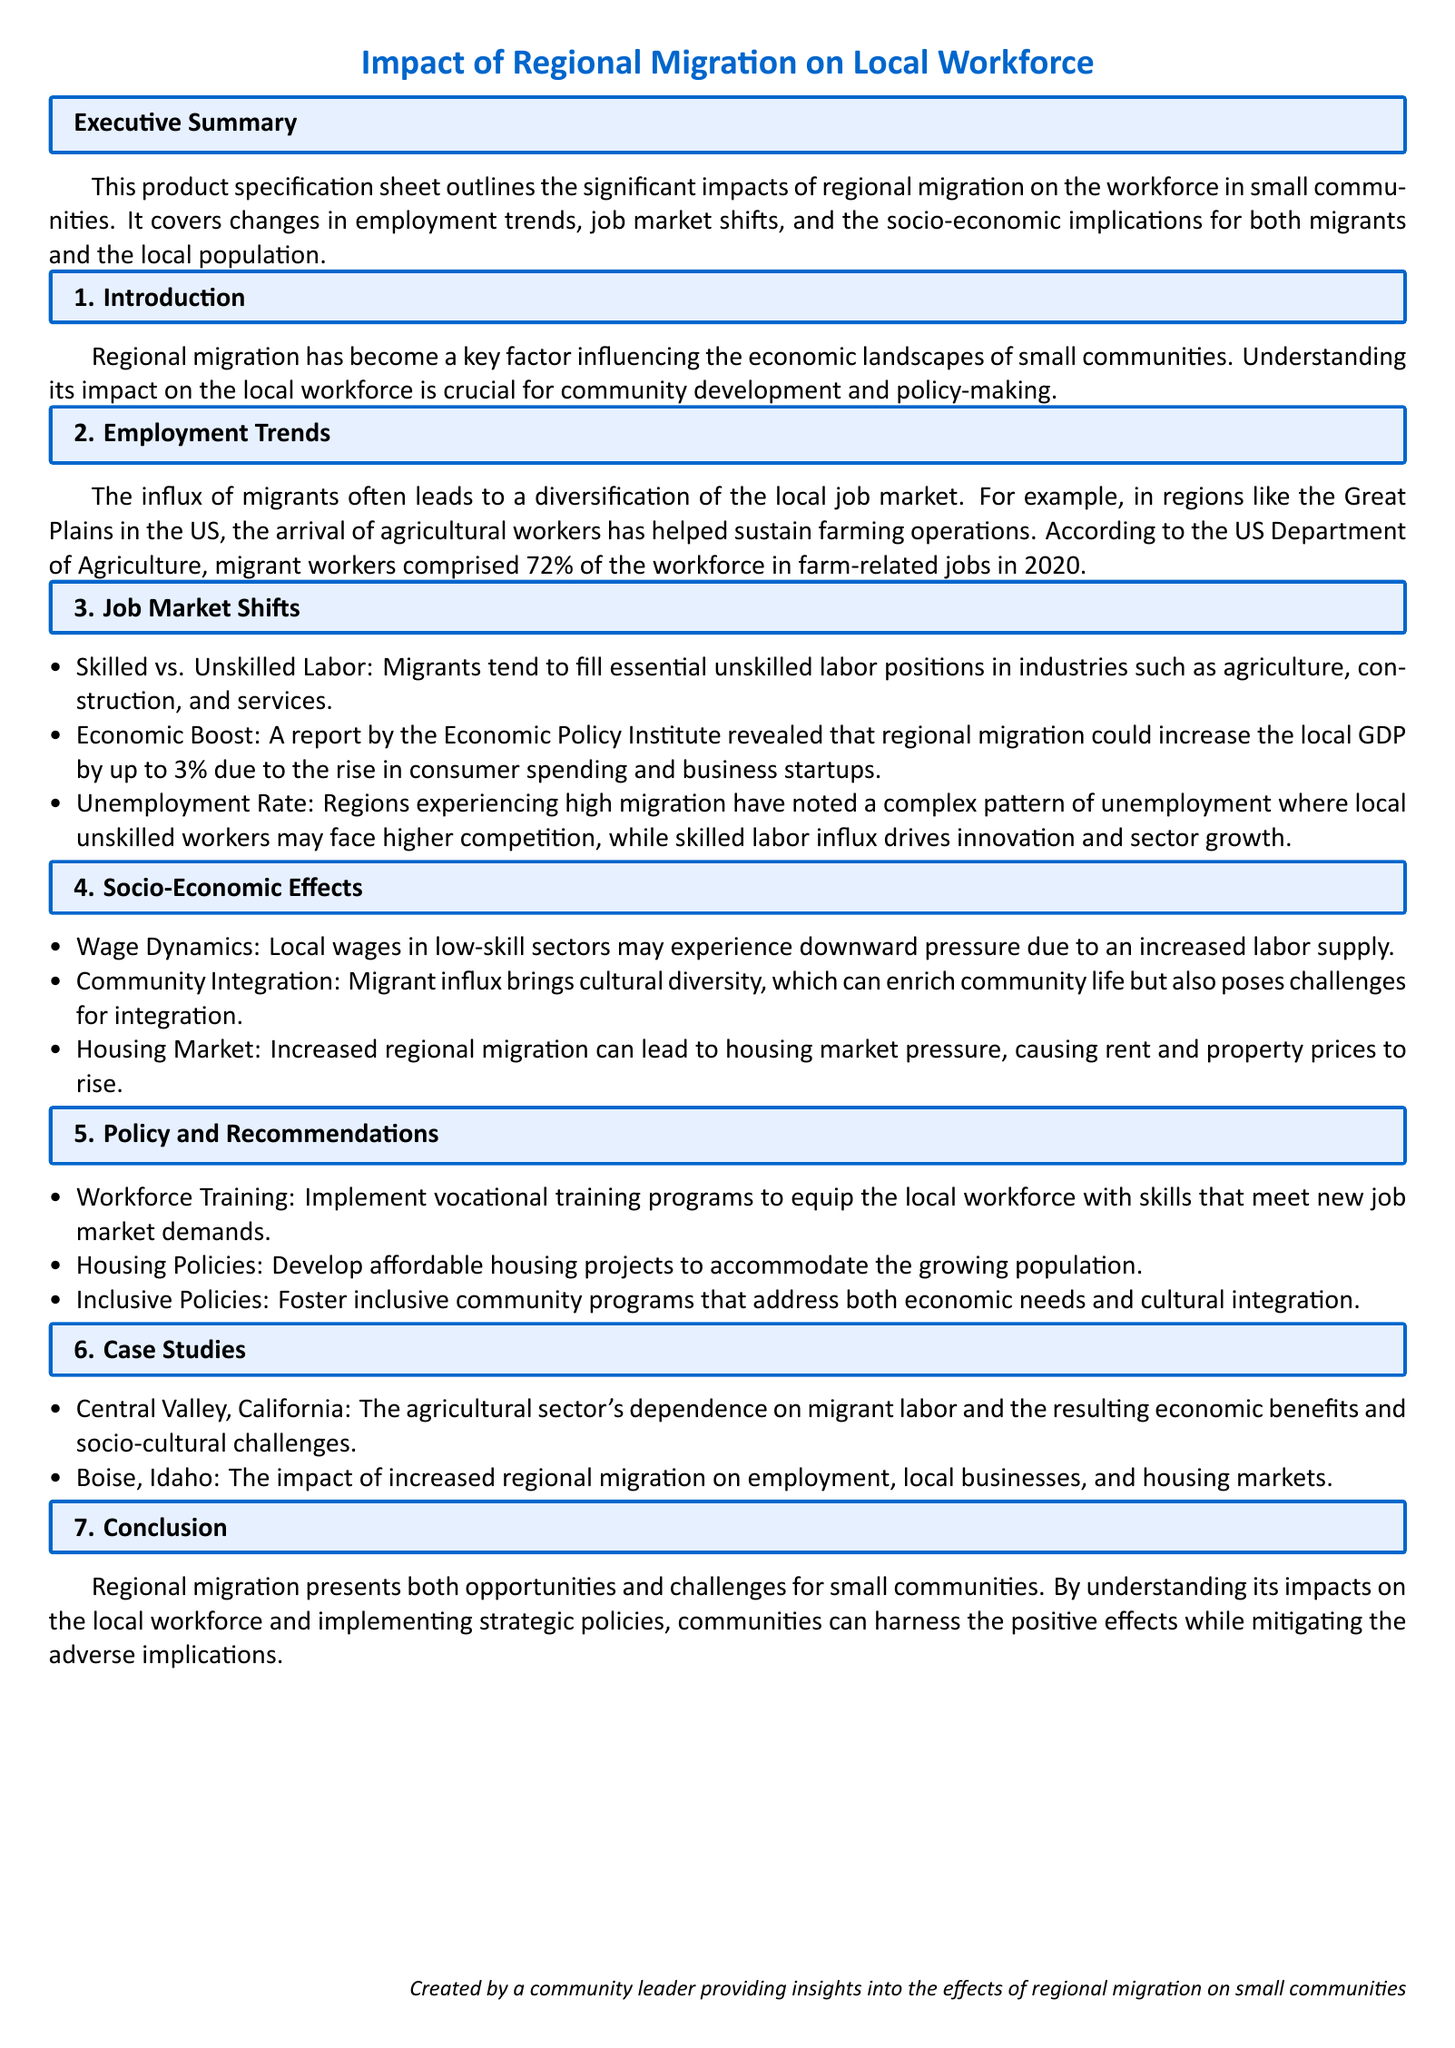what percentage of farm-related jobs were filled by migrant workers in 2020? The document states that migrant workers comprised 72% of the workforce in farm-related jobs in 2020.
Answer: 72% what is the potential increase in local GDP due to regional migration? According to the Economic Policy Institute, regional migration could increase the local GDP by up to 3%.
Answer: 3% what are two sectors where migrants tend to fill unskilled labor positions? The document lists agriculture, construction, and services as sectors where migrants fill unskilled labor positions.
Answer: agriculture, construction what socio-economic challenge is mentioned regarding community integration? The document notes that the influx of migrants poses challenges for integration into the community.
Answer: challenges for integration which state is highlighted for its dependence on migrant labor in agriculture? Central Valley, California is provided as a case study for its dependence on migrant labor in the agricultural sector.
Answer: California what type of training programs does the document recommend for the local workforce? The recommended programs are vocational training programs to equip the local workforce with relevant skills.
Answer: vocational training how do local wages in low-skill sectors change due to increased labor supply? The document mentions that local wages may experience downward pressure due to the increased labor supply.
Answer: downward pressure what does the document suggest as a policy to address housing market pressure? It suggests developing affordable housing projects to accommodate the growing population.
Answer: affordable housing projects 